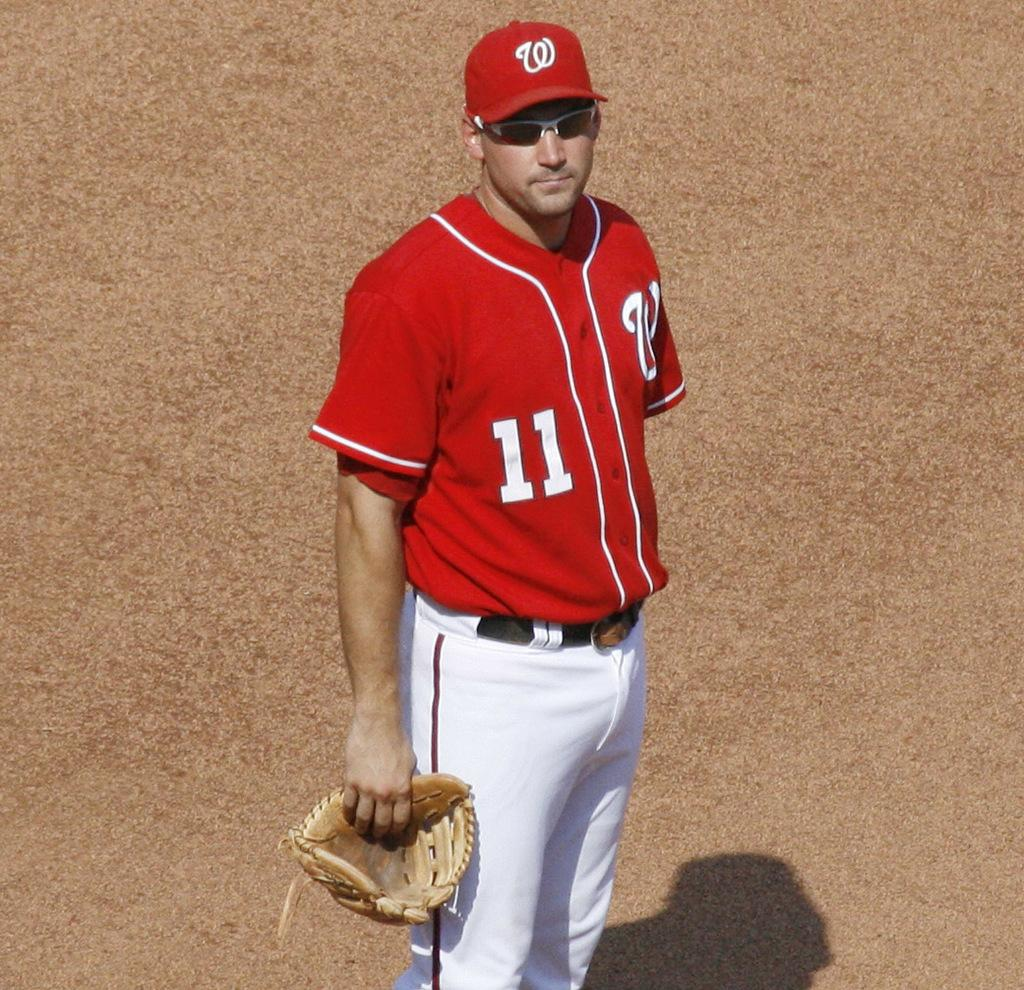<image>
Share a concise interpretation of the image provided. A player with number 11 on his red jersey holds a mitt in his right hand. 